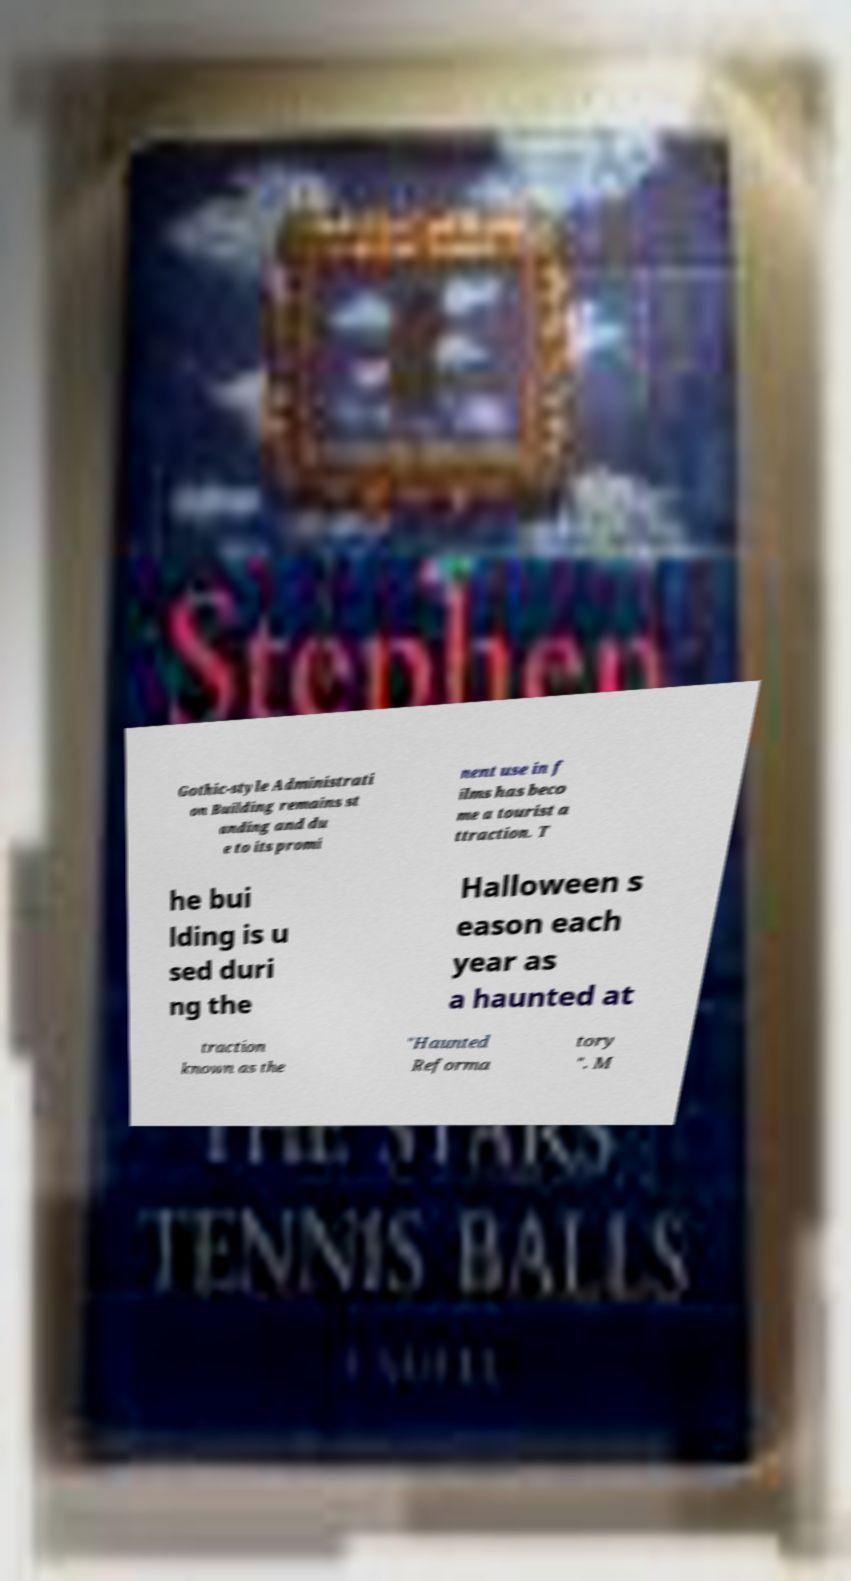What messages or text are displayed in this image? I need them in a readable, typed format. Gothic-style Administrati on Building remains st anding and du e to its promi nent use in f ilms has beco me a tourist a ttraction. T he bui lding is u sed duri ng the Halloween s eason each year as a haunted at traction known as the "Haunted Reforma tory ". M 